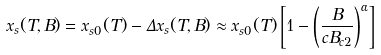<formula> <loc_0><loc_0><loc_500><loc_500>x _ { s } ( T , B ) = x _ { s 0 } ( T ) - \Delta x _ { s } ( T , B ) \approx x _ { s 0 } ( T ) \left [ 1 - \left ( \frac { B } { c B _ { c 2 } } \right ) ^ { \alpha } \right ]</formula> 